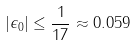Convert formula to latex. <formula><loc_0><loc_0><loc_500><loc_500>| \epsilon _ { 0 } | \leq \frac { 1 } { 1 7 } \approx 0 . 0 5 9</formula> 